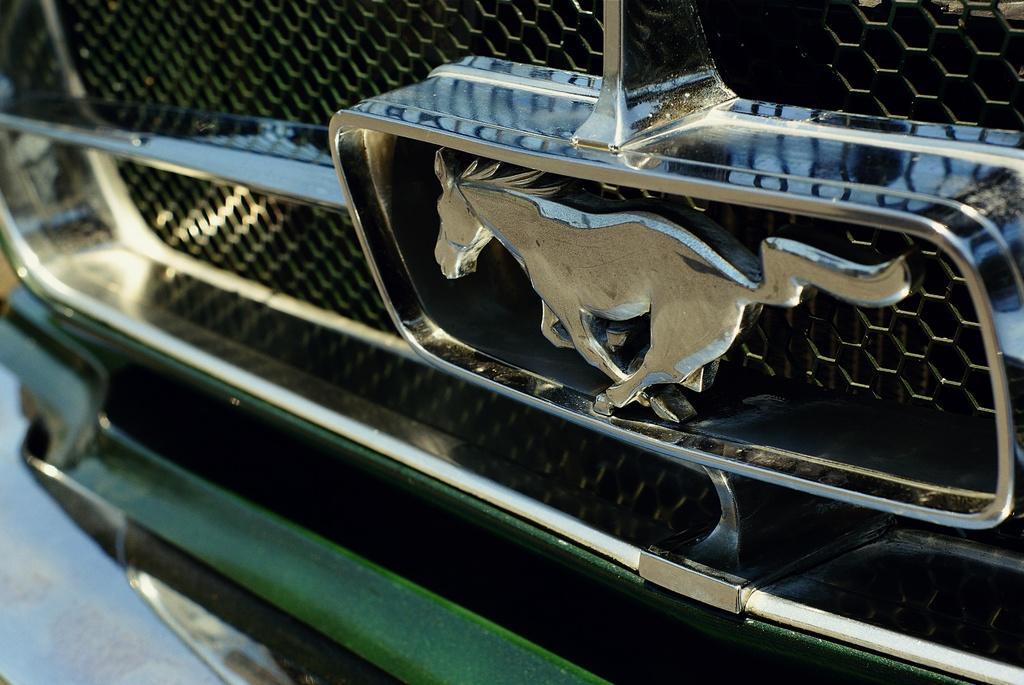In one or two sentences, can you explain what this image depicts? This picture contains a vehicle in green color. We see the logo of the horse on the vehicle. 